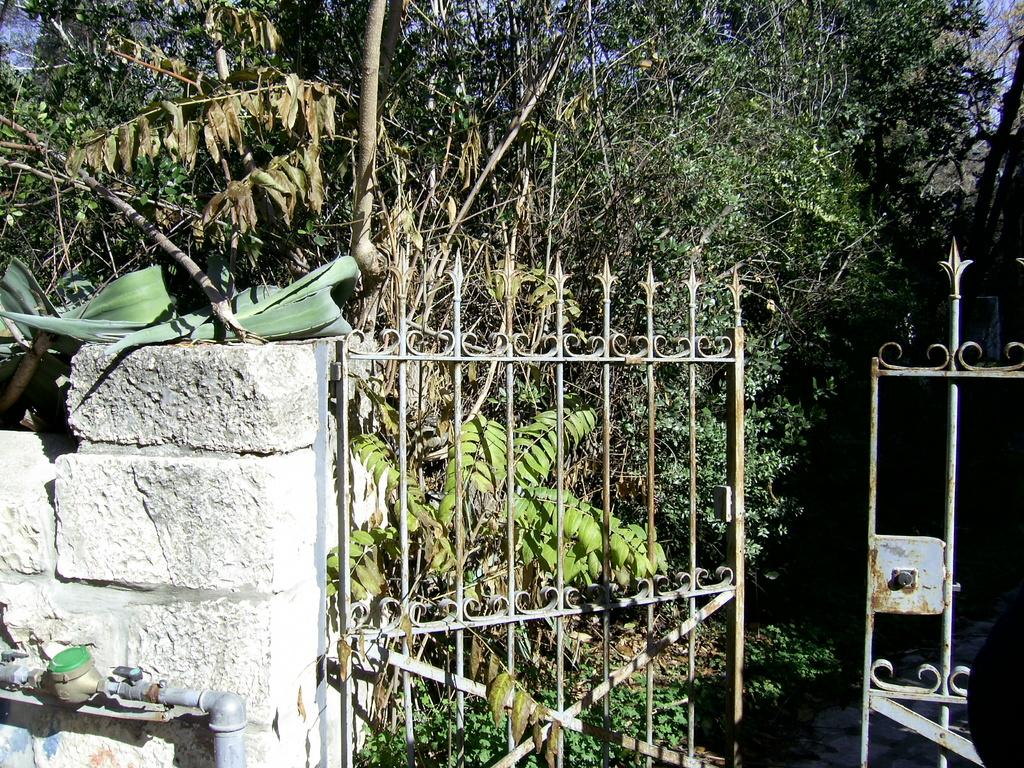What type of structure can be seen in the image? There is a wall in the image. Are there any openings in the wall? Yes, there are gates in the image. What can be seen in the background of the image? There are trees in the background of the image. What is the purpose of the pipe visible in the image? The purpose of the pipe is not specified in the image, but it may be part of a plumbing or irrigation system. What type of attraction is visible in the image? There is no attraction present in the image; it features a wall, gates, trees, and a pipe. Can you read the note that is attached to the wall in the image? There is no note attached to the wall in the image. 